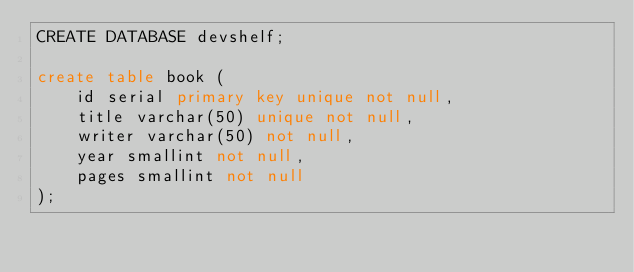Convert code to text. <code><loc_0><loc_0><loc_500><loc_500><_SQL_>CREATE DATABASE devshelf;

create table book (
    id serial primary key unique not null,
    title varchar(50) unique not null,
    writer varchar(50) not null,
    year smallint not null,
    pages smallint not null
);</code> 